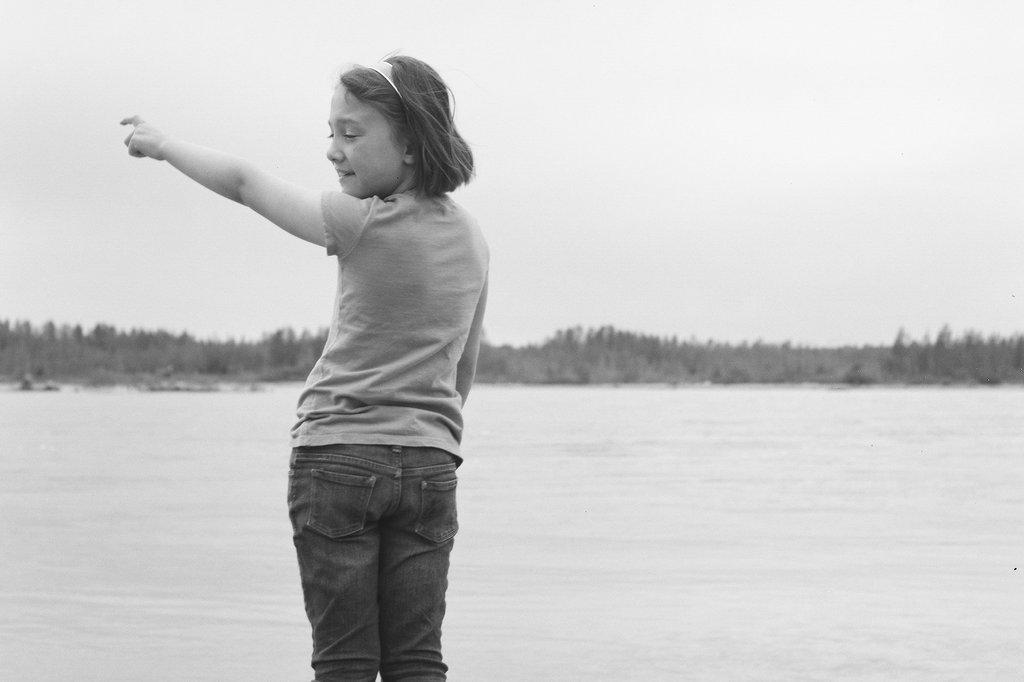What is the color scheme of the image? The image is black and white. Who or what is the main subject in the image? There is a girl in the center of the image. What can be seen in the background of the image? There are trees in the background of the image. What natural element is visible in the image? There is water visible in the image. What is the title of the book the girl is reading in the image? There is no book or title visible in the image; it is a black and white photograph of a girl with trees and water in the background. 